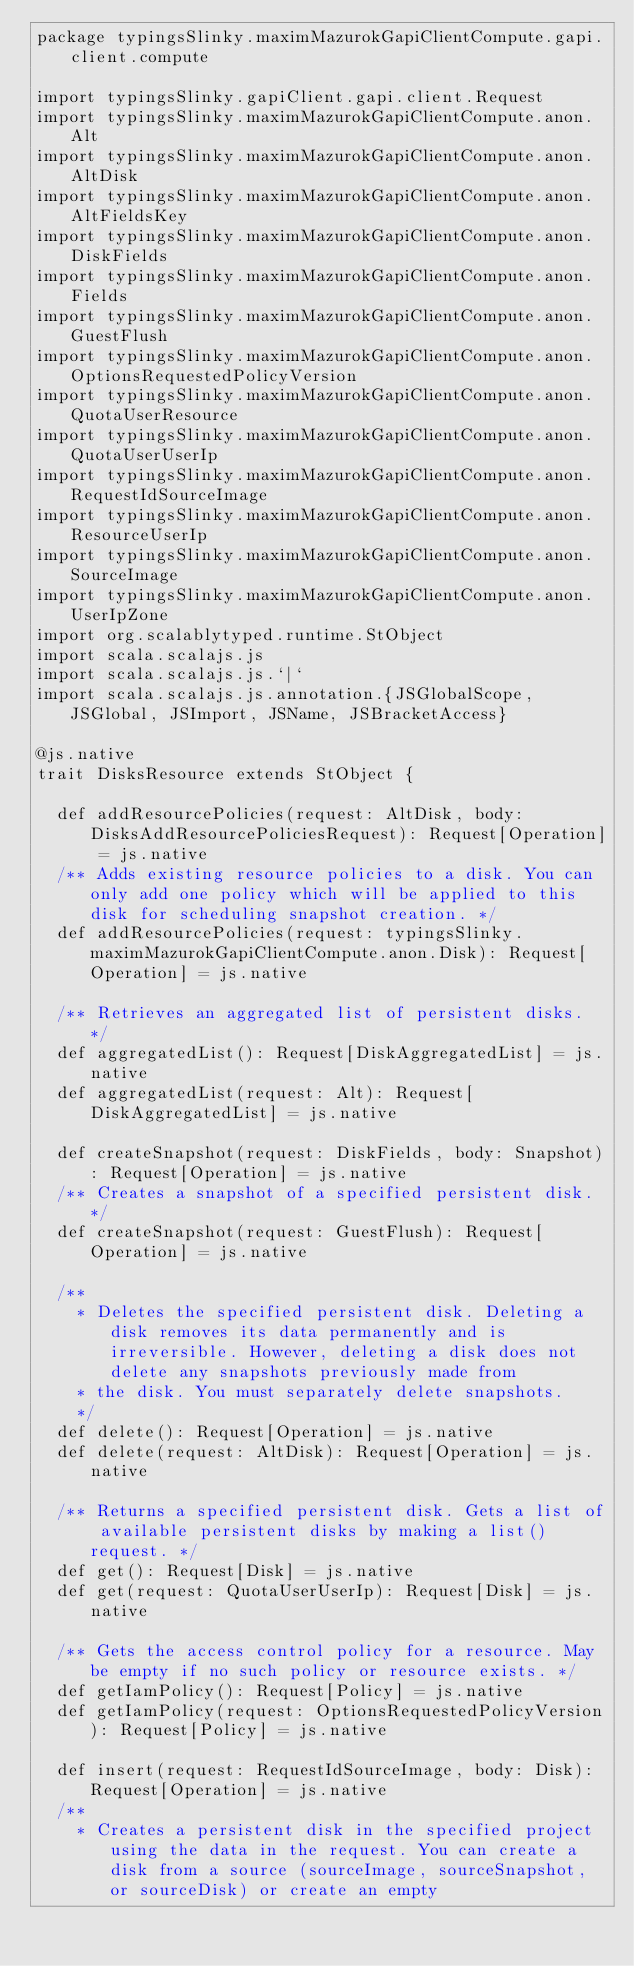Convert code to text. <code><loc_0><loc_0><loc_500><loc_500><_Scala_>package typingsSlinky.maximMazurokGapiClientCompute.gapi.client.compute

import typingsSlinky.gapiClient.gapi.client.Request
import typingsSlinky.maximMazurokGapiClientCompute.anon.Alt
import typingsSlinky.maximMazurokGapiClientCompute.anon.AltDisk
import typingsSlinky.maximMazurokGapiClientCompute.anon.AltFieldsKey
import typingsSlinky.maximMazurokGapiClientCompute.anon.DiskFields
import typingsSlinky.maximMazurokGapiClientCompute.anon.Fields
import typingsSlinky.maximMazurokGapiClientCompute.anon.GuestFlush
import typingsSlinky.maximMazurokGapiClientCompute.anon.OptionsRequestedPolicyVersion
import typingsSlinky.maximMazurokGapiClientCompute.anon.QuotaUserResource
import typingsSlinky.maximMazurokGapiClientCompute.anon.QuotaUserUserIp
import typingsSlinky.maximMazurokGapiClientCompute.anon.RequestIdSourceImage
import typingsSlinky.maximMazurokGapiClientCompute.anon.ResourceUserIp
import typingsSlinky.maximMazurokGapiClientCompute.anon.SourceImage
import typingsSlinky.maximMazurokGapiClientCompute.anon.UserIpZone
import org.scalablytyped.runtime.StObject
import scala.scalajs.js
import scala.scalajs.js.`|`
import scala.scalajs.js.annotation.{JSGlobalScope, JSGlobal, JSImport, JSName, JSBracketAccess}

@js.native
trait DisksResource extends StObject {
  
  def addResourcePolicies(request: AltDisk, body: DisksAddResourcePoliciesRequest): Request[Operation] = js.native
  /** Adds existing resource policies to a disk. You can only add one policy which will be applied to this disk for scheduling snapshot creation. */
  def addResourcePolicies(request: typingsSlinky.maximMazurokGapiClientCompute.anon.Disk): Request[Operation] = js.native
  
  /** Retrieves an aggregated list of persistent disks. */
  def aggregatedList(): Request[DiskAggregatedList] = js.native
  def aggregatedList(request: Alt): Request[DiskAggregatedList] = js.native
  
  def createSnapshot(request: DiskFields, body: Snapshot): Request[Operation] = js.native
  /** Creates a snapshot of a specified persistent disk. */
  def createSnapshot(request: GuestFlush): Request[Operation] = js.native
  
  /**
    * Deletes the specified persistent disk. Deleting a disk removes its data permanently and is irreversible. However, deleting a disk does not delete any snapshots previously made from
    * the disk. You must separately delete snapshots.
    */
  def delete(): Request[Operation] = js.native
  def delete(request: AltDisk): Request[Operation] = js.native
  
  /** Returns a specified persistent disk. Gets a list of available persistent disks by making a list() request. */
  def get(): Request[Disk] = js.native
  def get(request: QuotaUserUserIp): Request[Disk] = js.native
  
  /** Gets the access control policy for a resource. May be empty if no such policy or resource exists. */
  def getIamPolicy(): Request[Policy] = js.native
  def getIamPolicy(request: OptionsRequestedPolicyVersion): Request[Policy] = js.native
  
  def insert(request: RequestIdSourceImage, body: Disk): Request[Operation] = js.native
  /**
    * Creates a persistent disk in the specified project using the data in the request. You can create a disk from a source (sourceImage, sourceSnapshot, or sourceDisk) or create an empty</code> 